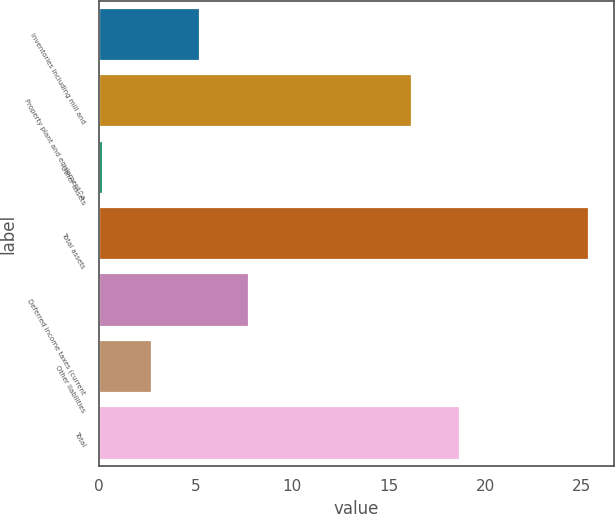<chart> <loc_0><loc_0><loc_500><loc_500><bar_chart><fcel>Inventories including mill and<fcel>Property plant and equipment^a<fcel>Other assets<fcel>Total assets<fcel>Deferred income taxes (current<fcel>Other liabilities<fcel>Total<nl><fcel>5.24<fcel>16.2<fcel>0.2<fcel>25.4<fcel>7.76<fcel>2.72<fcel>18.72<nl></chart> 